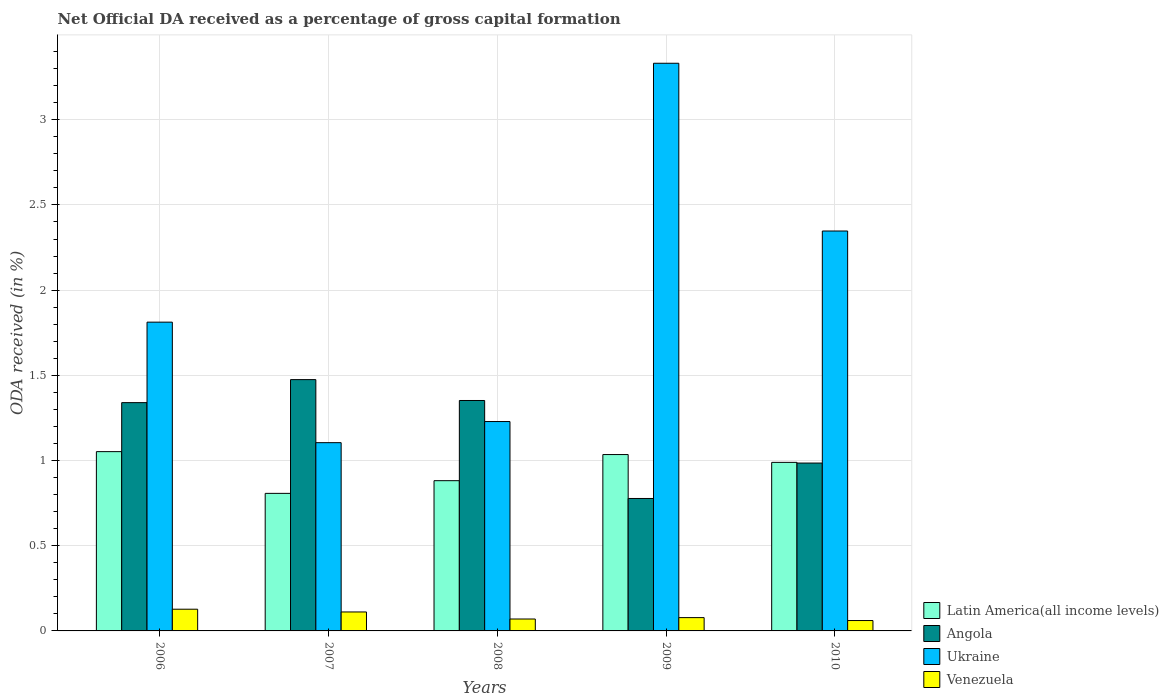How many different coloured bars are there?
Offer a terse response. 4. Are the number of bars per tick equal to the number of legend labels?
Give a very brief answer. Yes. How many bars are there on the 1st tick from the left?
Your answer should be very brief. 4. How many bars are there on the 3rd tick from the right?
Ensure brevity in your answer.  4. What is the net ODA received in Angola in 2009?
Your answer should be compact. 0.78. Across all years, what is the maximum net ODA received in Ukraine?
Your response must be concise. 3.33. Across all years, what is the minimum net ODA received in Angola?
Give a very brief answer. 0.78. In which year was the net ODA received in Latin America(all income levels) maximum?
Your answer should be very brief. 2006. In which year was the net ODA received in Latin America(all income levels) minimum?
Provide a succinct answer. 2007. What is the total net ODA received in Angola in the graph?
Your answer should be very brief. 5.93. What is the difference between the net ODA received in Latin America(all income levels) in 2008 and that in 2009?
Make the answer very short. -0.15. What is the difference between the net ODA received in Ukraine in 2010 and the net ODA received in Latin America(all income levels) in 2006?
Provide a short and direct response. 1.29. What is the average net ODA received in Latin America(all income levels) per year?
Your response must be concise. 0.95. In the year 2007, what is the difference between the net ODA received in Angola and net ODA received in Ukraine?
Ensure brevity in your answer.  0.37. In how many years, is the net ODA received in Angola greater than 2.5 %?
Offer a terse response. 0. What is the ratio of the net ODA received in Angola in 2007 to that in 2009?
Your answer should be very brief. 1.9. Is the net ODA received in Venezuela in 2009 less than that in 2010?
Make the answer very short. No. What is the difference between the highest and the second highest net ODA received in Angola?
Your answer should be very brief. 0.12. What is the difference between the highest and the lowest net ODA received in Angola?
Ensure brevity in your answer.  0.7. Is the sum of the net ODA received in Angola in 2007 and 2010 greater than the maximum net ODA received in Venezuela across all years?
Your answer should be compact. Yes. What does the 4th bar from the left in 2006 represents?
Your answer should be compact. Venezuela. What does the 2nd bar from the right in 2010 represents?
Offer a very short reply. Ukraine. What is the difference between two consecutive major ticks on the Y-axis?
Provide a succinct answer. 0.5. Are the values on the major ticks of Y-axis written in scientific E-notation?
Your answer should be compact. No. Does the graph contain any zero values?
Provide a short and direct response. No. Does the graph contain grids?
Make the answer very short. Yes. What is the title of the graph?
Your answer should be compact. Net Official DA received as a percentage of gross capital formation. What is the label or title of the X-axis?
Provide a short and direct response. Years. What is the label or title of the Y-axis?
Provide a short and direct response. ODA received (in %). What is the ODA received (in %) in Latin America(all income levels) in 2006?
Keep it short and to the point. 1.05. What is the ODA received (in %) in Angola in 2006?
Offer a terse response. 1.34. What is the ODA received (in %) in Ukraine in 2006?
Provide a succinct answer. 1.81. What is the ODA received (in %) of Venezuela in 2006?
Your answer should be compact. 0.13. What is the ODA received (in %) in Latin America(all income levels) in 2007?
Your response must be concise. 0.81. What is the ODA received (in %) of Angola in 2007?
Your answer should be very brief. 1.47. What is the ODA received (in %) in Ukraine in 2007?
Offer a terse response. 1.1. What is the ODA received (in %) in Venezuela in 2007?
Give a very brief answer. 0.11. What is the ODA received (in %) in Latin America(all income levels) in 2008?
Offer a very short reply. 0.88. What is the ODA received (in %) in Angola in 2008?
Your answer should be very brief. 1.35. What is the ODA received (in %) in Ukraine in 2008?
Offer a terse response. 1.23. What is the ODA received (in %) in Venezuela in 2008?
Provide a short and direct response. 0.07. What is the ODA received (in %) in Latin America(all income levels) in 2009?
Make the answer very short. 1.04. What is the ODA received (in %) in Angola in 2009?
Provide a short and direct response. 0.78. What is the ODA received (in %) in Ukraine in 2009?
Keep it short and to the point. 3.33. What is the ODA received (in %) of Venezuela in 2009?
Keep it short and to the point. 0.08. What is the ODA received (in %) in Latin America(all income levels) in 2010?
Make the answer very short. 0.99. What is the ODA received (in %) of Angola in 2010?
Make the answer very short. 0.99. What is the ODA received (in %) of Ukraine in 2010?
Ensure brevity in your answer.  2.35. What is the ODA received (in %) of Venezuela in 2010?
Ensure brevity in your answer.  0.06. Across all years, what is the maximum ODA received (in %) in Latin America(all income levels)?
Offer a terse response. 1.05. Across all years, what is the maximum ODA received (in %) in Angola?
Offer a very short reply. 1.47. Across all years, what is the maximum ODA received (in %) of Ukraine?
Offer a terse response. 3.33. Across all years, what is the maximum ODA received (in %) in Venezuela?
Offer a very short reply. 0.13. Across all years, what is the minimum ODA received (in %) in Latin America(all income levels)?
Ensure brevity in your answer.  0.81. Across all years, what is the minimum ODA received (in %) of Angola?
Offer a terse response. 0.78. Across all years, what is the minimum ODA received (in %) in Ukraine?
Give a very brief answer. 1.1. Across all years, what is the minimum ODA received (in %) of Venezuela?
Provide a short and direct response. 0.06. What is the total ODA received (in %) in Latin America(all income levels) in the graph?
Provide a succinct answer. 4.77. What is the total ODA received (in %) of Angola in the graph?
Make the answer very short. 5.93. What is the total ODA received (in %) of Ukraine in the graph?
Your response must be concise. 9.82. What is the total ODA received (in %) in Venezuela in the graph?
Your response must be concise. 0.45. What is the difference between the ODA received (in %) of Latin America(all income levels) in 2006 and that in 2007?
Ensure brevity in your answer.  0.24. What is the difference between the ODA received (in %) of Angola in 2006 and that in 2007?
Give a very brief answer. -0.14. What is the difference between the ODA received (in %) in Ukraine in 2006 and that in 2007?
Keep it short and to the point. 0.71. What is the difference between the ODA received (in %) of Venezuela in 2006 and that in 2007?
Make the answer very short. 0.02. What is the difference between the ODA received (in %) of Latin America(all income levels) in 2006 and that in 2008?
Provide a succinct answer. 0.17. What is the difference between the ODA received (in %) in Angola in 2006 and that in 2008?
Provide a succinct answer. -0.01. What is the difference between the ODA received (in %) of Ukraine in 2006 and that in 2008?
Provide a succinct answer. 0.58. What is the difference between the ODA received (in %) in Venezuela in 2006 and that in 2008?
Your response must be concise. 0.06. What is the difference between the ODA received (in %) in Latin America(all income levels) in 2006 and that in 2009?
Provide a succinct answer. 0.02. What is the difference between the ODA received (in %) of Angola in 2006 and that in 2009?
Make the answer very short. 0.56. What is the difference between the ODA received (in %) of Ukraine in 2006 and that in 2009?
Ensure brevity in your answer.  -1.52. What is the difference between the ODA received (in %) in Venezuela in 2006 and that in 2009?
Offer a terse response. 0.05. What is the difference between the ODA received (in %) in Latin America(all income levels) in 2006 and that in 2010?
Provide a succinct answer. 0.06. What is the difference between the ODA received (in %) in Angola in 2006 and that in 2010?
Keep it short and to the point. 0.35. What is the difference between the ODA received (in %) of Ukraine in 2006 and that in 2010?
Keep it short and to the point. -0.53. What is the difference between the ODA received (in %) in Venezuela in 2006 and that in 2010?
Your answer should be very brief. 0.07. What is the difference between the ODA received (in %) of Latin America(all income levels) in 2007 and that in 2008?
Make the answer very short. -0.07. What is the difference between the ODA received (in %) of Angola in 2007 and that in 2008?
Offer a terse response. 0.12. What is the difference between the ODA received (in %) of Ukraine in 2007 and that in 2008?
Your answer should be very brief. -0.12. What is the difference between the ODA received (in %) in Venezuela in 2007 and that in 2008?
Give a very brief answer. 0.04. What is the difference between the ODA received (in %) of Latin America(all income levels) in 2007 and that in 2009?
Your answer should be compact. -0.23. What is the difference between the ODA received (in %) in Angola in 2007 and that in 2009?
Make the answer very short. 0.7. What is the difference between the ODA received (in %) of Ukraine in 2007 and that in 2009?
Give a very brief answer. -2.23. What is the difference between the ODA received (in %) in Venezuela in 2007 and that in 2009?
Give a very brief answer. 0.03. What is the difference between the ODA received (in %) in Latin America(all income levels) in 2007 and that in 2010?
Give a very brief answer. -0.18. What is the difference between the ODA received (in %) of Angola in 2007 and that in 2010?
Your answer should be very brief. 0.49. What is the difference between the ODA received (in %) in Ukraine in 2007 and that in 2010?
Your response must be concise. -1.24. What is the difference between the ODA received (in %) of Venezuela in 2007 and that in 2010?
Offer a terse response. 0.05. What is the difference between the ODA received (in %) of Latin America(all income levels) in 2008 and that in 2009?
Offer a very short reply. -0.15. What is the difference between the ODA received (in %) of Angola in 2008 and that in 2009?
Offer a very short reply. 0.58. What is the difference between the ODA received (in %) of Ukraine in 2008 and that in 2009?
Keep it short and to the point. -2.1. What is the difference between the ODA received (in %) in Venezuela in 2008 and that in 2009?
Give a very brief answer. -0.01. What is the difference between the ODA received (in %) of Latin America(all income levels) in 2008 and that in 2010?
Give a very brief answer. -0.11. What is the difference between the ODA received (in %) of Angola in 2008 and that in 2010?
Offer a terse response. 0.37. What is the difference between the ODA received (in %) of Ukraine in 2008 and that in 2010?
Keep it short and to the point. -1.12. What is the difference between the ODA received (in %) in Venezuela in 2008 and that in 2010?
Make the answer very short. 0.01. What is the difference between the ODA received (in %) in Latin America(all income levels) in 2009 and that in 2010?
Your response must be concise. 0.05. What is the difference between the ODA received (in %) of Angola in 2009 and that in 2010?
Offer a very short reply. -0.21. What is the difference between the ODA received (in %) of Ukraine in 2009 and that in 2010?
Provide a succinct answer. 0.98. What is the difference between the ODA received (in %) of Venezuela in 2009 and that in 2010?
Give a very brief answer. 0.02. What is the difference between the ODA received (in %) in Latin America(all income levels) in 2006 and the ODA received (in %) in Angola in 2007?
Give a very brief answer. -0.42. What is the difference between the ODA received (in %) in Latin America(all income levels) in 2006 and the ODA received (in %) in Ukraine in 2007?
Offer a terse response. -0.05. What is the difference between the ODA received (in %) in Latin America(all income levels) in 2006 and the ODA received (in %) in Venezuela in 2007?
Ensure brevity in your answer.  0.94. What is the difference between the ODA received (in %) in Angola in 2006 and the ODA received (in %) in Ukraine in 2007?
Provide a short and direct response. 0.23. What is the difference between the ODA received (in %) of Angola in 2006 and the ODA received (in %) of Venezuela in 2007?
Provide a succinct answer. 1.23. What is the difference between the ODA received (in %) in Ukraine in 2006 and the ODA received (in %) in Venezuela in 2007?
Ensure brevity in your answer.  1.7. What is the difference between the ODA received (in %) in Latin America(all income levels) in 2006 and the ODA received (in %) in Angola in 2008?
Give a very brief answer. -0.3. What is the difference between the ODA received (in %) of Latin America(all income levels) in 2006 and the ODA received (in %) of Ukraine in 2008?
Provide a succinct answer. -0.18. What is the difference between the ODA received (in %) in Latin America(all income levels) in 2006 and the ODA received (in %) in Venezuela in 2008?
Your answer should be compact. 0.98. What is the difference between the ODA received (in %) in Angola in 2006 and the ODA received (in %) in Ukraine in 2008?
Make the answer very short. 0.11. What is the difference between the ODA received (in %) of Angola in 2006 and the ODA received (in %) of Venezuela in 2008?
Keep it short and to the point. 1.27. What is the difference between the ODA received (in %) in Ukraine in 2006 and the ODA received (in %) in Venezuela in 2008?
Give a very brief answer. 1.74. What is the difference between the ODA received (in %) in Latin America(all income levels) in 2006 and the ODA received (in %) in Angola in 2009?
Offer a terse response. 0.27. What is the difference between the ODA received (in %) of Latin America(all income levels) in 2006 and the ODA received (in %) of Ukraine in 2009?
Offer a terse response. -2.28. What is the difference between the ODA received (in %) in Latin America(all income levels) in 2006 and the ODA received (in %) in Venezuela in 2009?
Your response must be concise. 0.97. What is the difference between the ODA received (in %) of Angola in 2006 and the ODA received (in %) of Ukraine in 2009?
Provide a short and direct response. -1.99. What is the difference between the ODA received (in %) of Angola in 2006 and the ODA received (in %) of Venezuela in 2009?
Keep it short and to the point. 1.26. What is the difference between the ODA received (in %) of Ukraine in 2006 and the ODA received (in %) of Venezuela in 2009?
Your answer should be compact. 1.73. What is the difference between the ODA received (in %) in Latin America(all income levels) in 2006 and the ODA received (in %) in Angola in 2010?
Your answer should be compact. 0.07. What is the difference between the ODA received (in %) of Latin America(all income levels) in 2006 and the ODA received (in %) of Ukraine in 2010?
Your answer should be compact. -1.29. What is the difference between the ODA received (in %) in Latin America(all income levels) in 2006 and the ODA received (in %) in Venezuela in 2010?
Keep it short and to the point. 0.99. What is the difference between the ODA received (in %) of Angola in 2006 and the ODA received (in %) of Ukraine in 2010?
Give a very brief answer. -1.01. What is the difference between the ODA received (in %) in Angola in 2006 and the ODA received (in %) in Venezuela in 2010?
Make the answer very short. 1.28. What is the difference between the ODA received (in %) of Ukraine in 2006 and the ODA received (in %) of Venezuela in 2010?
Your response must be concise. 1.75. What is the difference between the ODA received (in %) in Latin America(all income levels) in 2007 and the ODA received (in %) in Angola in 2008?
Your response must be concise. -0.55. What is the difference between the ODA received (in %) of Latin America(all income levels) in 2007 and the ODA received (in %) of Ukraine in 2008?
Ensure brevity in your answer.  -0.42. What is the difference between the ODA received (in %) in Latin America(all income levels) in 2007 and the ODA received (in %) in Venezuela in 2008?
Provide a short and direct response. 0.74. What is the difference between the ODA received (in %) of Angola in 2007 and the ODA received (in %) of Ukraine in 2008?
Your answer should be compact. 0.25. What is the difference between the ODA received (in %) of Angola in 2007 and the ODA received (in %) of Venezuela in 2008?
Your answer should be very brief. 1.4. What is the difference between the ODA received (in %) of Ukraine in 2007 and the ODA received (in %) of Venezuela in 2008?
Your response must be concise. 1.03. What is the difference between the ODA received (in %) in Latin America(all income levels) in 2007 and the ODA received (in %) in Angola in 2009?
Keep it short and to the point. 0.03. What is the difference between the ODA received (in %) in Latin America(all income levels) in 2007 and the ODA received (in %) in Ukraine in 2009?
Offer a terse response. -2.52. What is the difference between the ODA received (in %) of Latin America(all income levels) in 2007 and the ODA received (in %) of Venezuela in 2009?
Your response must be concise. 0.73. What is the difference between the ODA received (in %) of Angola in 2007 and the ODA received (in %) of Ukraine in 2009?
Ensure brevity in your answer.  -1.86. What is the difference between the ODA received (in %) in Angola in 2007 and the ODA received (in %) in Venezuela in 2009?
Your answer should be very brief. 1.4. What is the difference between the ODA received (in %) in Ukraine in 2007 and the ODA received (in %) in Venezuela in 2009?
Your answer should be compact. 1.03. What is the difference between the ODA received (in %) in Latin America(all income levels) in 2007 and the ODA received (in %) in Angola in 2010?
Ensure brevity in your answer.  -0.18. What is the difference between the ODA received (in %) in Latin America(all income levels) in 2007 and the ODA received (in %) in Ukraine in 2010?
Your answer should be compact. -1.54. What is the difference between the ODA received (in %) in Latin America(all income levels) in 2007 and the ODA received (in %) in Venezuela in 2010?
Offer a very short reply. 0.75. What is the difference between the ODA received (in %) in Angola in 2007 and the ODA received (in %) in Ukraine in 2010?
Your answer should be compact. -0.87. What is the difference between the ODA received (in %) in Angola in 2007 and the ODA received (in %) in Venezuela in 2010?
Offer a terse response. 1.41. What is the difference between the ODA received (in %) of Ukraine in 2007 and the ODA received (in %) of Venezuela in 2010?
Provide a succinct answer. 1.04. What is the difference between the ODA received (in %) in Latin America(all income levels) in 2008 and the ODA received (in %) in Angola in 2009?
Offer a terse response. 0.1. What is the difference between the ODA received (in %) in Latin America(all income levels) in 2008 and the ODA received (in %) in Ukraine in 2009?
Offer a terse response. -2.45. What is the difference between the ODA received (in %) of Latin America(all income levels) in 2008 and the ODA received (in %) of Venezuela in 2009?
Your answer should be compact. 0.8. What is the difference between the ODA received (in %) of Angola in 2008 and the ODA received (in %) of Ukraine in 2009?
Ensure brevity in your answer.  -1.98. What is the difference between the ODA received (in %) of Angola in 2008 and the ODA received (in %) of Venezuela in 2009?
Keep it short and to the point. 1.27. What is the difference between the ODA received (in %) in Ukraine in 2008 and the ODA received (in %) in Venezuela in 2009?
Provide a short and direct response. 1.15. What is the difference between the ODA received (in %) of Latin America(all income levels) in 2008 and the ODA received (in %) of Angola in 2010?
Your response must be concise. -0.1. What is the difference between the ODA received (in %) in Latin America(all income levels) in 2008 and the ODA received (in %) in Ukraine in 2010?
Ensure brevity in your answer.  -1.47. What is the difference between the ODA received (in %) of Latin America(all income levels) in 2008 and the ODA received (in %) of Venezuela in 2010?
Your answer should be compact. 0.82. What is the difference between the ODA received (in %) in Angola in 2008 and the ODA received (in %) in Ukraine in 2010?
Provide a succinct answer. -0.99. What is the difference between the ODA received (in %) in Angola in 2008 and the ODA received (in %) in Venezuela in 2010?
Provide a short and direct response. 1.29. What is the difference between the ODA received (in %) in Ukraine in 2008 and the ODA received (in %) in Venezuela in 2010?
Your answer should be compact. 1.17. What is the difference between the ODA received (in %) in Latin America(all income levels) in 2009 and the ODA received (in %) in Angola in 2010?
Provide a succinct answer. 0.05. What is the difference between the ODA received (in %) of Latin America(all income levels) in 2009 and the ODA received (in %) of Ukraine in 2010?
Provide a succinct answer. -1.31. What is the difference between the ODA received (in %) in Latin America(all income levels) in 2009 and the ODA received (in %) in Venezuela in 2010?
Make the answer very short. 0.97. What is the difference between the ODA received (in %) of Angola in 2009 and the ODA received (in %) of Ukraine in 2010?
Your answer should be compact. -1.57. What is the difference between the ODA received (in %) of Angola in 2009 and the ODA received (in %) of Venezuela in 2010?
Make the answer very short. 0.72. What is the difference between the ODA received (in %) of Ukraine in 2009 and the ODA received (in %) of Venezuela in 2010?
Make the answer very short. 3.27. What is the average ODA received (in %) of Latin America(all income levels) per year?
Provide a short and direct response. 0.95. What is the average ODA received (in %) of Angola per year?
Your response must be concise. 1.19. What is the average ODA received (in %) in Ukraine per year?
Your answer should be very brief. 1.96. What is the average ODA received (in %) in Venezuela per year?
Make the answer very short. 0.09. In the year 2006, what is the difference between the ODA received (in %) in Latin America(all income levels) and ODA received (in %) in Angola?
Provide a short and direct response. -0.29. In the year 2006, what is the difference between the ODA received (in %) of Latin America(all income levels) and ODA received (in %) of Ukraine?
Keep it short and to the point. -0.76. In the year 2006, what is the difference between the ODA received (in %) of Latin America(all income levels) and ODA received (in %) of Venezuela?
Keep it short and to the point. 0.92. In the year 2006, what is the difference between the ODA received (in %) of Angola and ODA received (in %) of Ukraine?
Your answer should be very brief. -0.47. In the year 2006, what is the difference between the ODA received (in %) in Angola and ODA received (in %) in Venezuela?
Your answer should be very brief. 1.21. In the year 2006, what is the difference between the ODA received (in %) of Ukraine and ODA received (in %) of Venezuela?
Offer a terse response. 1.68. In the year 2007, what is the difference between the ODA received (in %) of Latin America(all income levels) and ODA received (in %) of Angola?
Give a very brief answer. -0.67. In the year 2007, what is the difference between the ODA received (in %) in Latin America(all income levels) and ODA received (in %) in Ukraine?
Provide a succinct answer. -0.3. In the year 2007, what is the difference between the ODA received (in %) in Latin America(all income levels) and ODA received (in %) in Venezuela?
Offer a terse response. 0.7. In the year 2007, what is the difference between the ODA received (in %) of Angola and ODA received (in %) of Ukraine?
Your answer should be compact. 0.37. In the year 2007, what is the difference between the ODA received (in %) of Angola and ODA received (in %) of Venezuela?
Provide a short and direct response. 1.36. In the year 2007, what is the difference between the ODA received (in %) in Ukraine and ODA received (in %) in Venezuela?
Offer a very short reply. 0.99. In the year 2008, what is the difference between the ODA received (in %) of Latin America(all income levels) and ODA received (in %) of Angola?
Your answer should be compact. -0.47. In the year 2008, what is the difference between the ODA received (in %) in Latin America(all income levels) and ODA received (in %) in Ukraine?
Provide a succinct answer. -0.35. In the year 2008, what is the difference between the ODA received (in %) of Latin America(all income levels) and ODA received (in %) of Venezuela?
Ensure brevity in your answer.  0.81. In the year 2008, what is the difference between the ODA received (in %) of Angola and ODA received (in %) of Ukraine?
Your response must be concise. 0.12. In the year 2008, what is the difference between the ODA received (in %) in Angola and ODA received (in %) in Venezuela?
Provide a succinct answer. 1.28. In the year 2008, what is the difference between the ODA received (in %) of Ukraine and ODA received (in %) of Venezuela?
Offer a very short reply. 1.16. In the year 2009, what is the difference between the ODA received (in %) of Latin America(all income levels) and ODA received (in %) of Angola?
Provide a succinct answer. 0.26. In the year 2009, what is the difference between the ODA received (in %) of Latin America(all income levels) and ODA received (in %) of Ukraine?
Give a very brief answer. -2.3. In the year 2009, what is the difference between the ODA received (in %) in Latin America(all income levels) and ODA received (in %) in Venezuela?
Provide a succinct answer. 0.96. In the year 2009, what is the difference between the ODA received (in %) in Angola and ODA received (in %) in Ukraine?
Give a very brief answer. -2.55. In the year 2009, what is the difference between the ODA received (in %) of Angola and ODA received (in %) of Venezuela?
Make the answer very short. 0.7. In the year 2009, what is the difference between the ODA received (in %) of Ukraine and ODA received (in %) of Venezuela?
Your response must be concise. 3.25. In the year 2010, what is the difference between the ODA received (in %) in Latin America(all income levels) and ODA received (in %) in Angola?
Your answer should be compact. 0. In the year 2010, what is the difference between the ODA received (in %) in Latin America(all income levels) and ODA received (in %) in Ukraine?
Offer a terse response. -1.36. In the year 2010, what is the difference between the ODA received (in %) in Latin America(all income levels) and ODA received (in %) in Venezuela?
Your response must be concise. 0.93. In the year 2010, what is the difference between the ODA received (in %) in Angola and ODA received (in %) in Ukraine?
Provide a short and direct response. -1.36. In the year 2010, what is the difference between the ODA received (in %) in Angola and ODA received (in %) in Venezuela?
Your answer should be compact. 0.92. In the year 2010, what is the difference between the ODA received (in %) of Ukraine and ODA received (in %) of Venezuela?
Offer a terse response. 2.29. What is the ratio of the ODA received (in %) in Latin America(all income levels) in 2006 to that in 2007?
Offer a very short reply. 1.3. What is the ratio of the ODA received (in %) of Angola in 2006 to that in 2007?
Offer a very short reply. 0.91. What is the ratio of the ODA received (in %) of Ukraine in 2006 to that in 2007?
Keep it short and to the point. 1.64. What is the ratio of the ODA received (in %) of Venezuela in 2006 to that in 2007?
Give a very brief answer. 1.15. What is the ratio of the ODA received (in %) in Latin America(all income levels) in 2006 to that in 2008?
Your answer should be compact. 1.19. What is the ratio of the ODA received (in %) in Ukraine in 2006 to that in 2008?
Your answer should be very brief. 1.47. What is the ratio of the ODA received (in %) in Venezuela in 2006 to that in 2008?
Give a very brief answer. 1.82. What is the ratio of the ODA received (in %) of Latin America(all income levels) in 2006 to that in 2009?
Give a very brief answer. 1.02. What is the ratio of the ODA received (in %) of Angola in 2006 to that in 2009?
Offer a terse response. 1.72. What is the ratio of the ODA received (in %) of Ukraine in 2006 to that in 2009?
Your answer should be compact. 0.54. What is the ratio of the ODA received (in %) of Venezuela in 2006 to that in 2009?
Provide a short and direct response. 1.63. What is the ratio of the ODA received (in %) in Latin America(all income levels) in 2006 to that in 2010?
Give a very brief answer. 1.06. What is the ratio of the ODA received (in %) in Angola in 2006 to that in 2010?
Your response must be concise. 1.36. What is the ratio of the ODA received (in %) of Ukraine in 2006 to that in 2010?
Give a very brief answer. 0.77. What is the ratio of the ODA received (in %) in Venezuela in 2006 to that in 2010?
Provide a short and direct response. 2.09. What is the ratio of the ODA received (in %) of Latin America(all income levels) in 2007 to that in 2008?
Your answer should be compact. 0.92. What is the ratio of the ODA received (in %) of Angola in 2007 to that in 2008?
Keep it short and to the point. 1.09. What is the ratio of the ODA received (in %) in Ukraine in 2007 to that in 2008?
Give a very brief answer. 0.9. What is the ratio of the ODA received (in %) in Venezuela in 2007 to that in 2008?
Make the answer very short. 1.59. What is the ratio of the ODA received (in %) in Latin America(all income levels) in 2007 to that in 2009?
Offer a very short reply. 0.78. What is the ratio of the ODA received (in %) of Angola in 2007 to that in 2009?
Offer a terse response. 1.9. What is the ratio of the ODA received (in %) in Ukraine in 2007 to that in 2009?
Keep it short and to the point. 0.33. What is the ratio of the ODA received (in %) in Venezuela in 2007 to that in 2009?
Provide a short and direct response. 1.43. What is the ratio of the ODA received (in %) in Latin America(all income levels) in 2007 to that in 2010?
Your response must be concise. 0.82. What is the ratio of the ODA received (in %) of Angola in 2007 to that in 2010?
Give a very brief answer. 1.5. What is the ratio of the ODA received (in %) in Ukraine in 2007 to that in 2010?
Provide a short and direct response. 0.47. What is the ratio of the ODA received (in %) in Venezuela in 2007 to that in 2010?
Your answer should be compact. 1.83. What is the ratio of the ODA received (in %) in Latin America(all income levels) in 2008 to that in 2009?
Your answer should be very brief. 0.85. What is the ratio of the ODA received (in %) of Angola in 2008 to that in 2009?
Provide a short and direct response. 1.74. What is the ratio of the ODA received (in %) in Ukraine in 2008 to that in 2009?
Provide a succinct answer. 0.37. What is the ratio of the ODA received (in %) of Venezuela in 2008 to that in 2009?
Give a very brief answer. 0.9. What is the ratio of the ODA received (in %) of Latin America(all income levels) in 2008 to that in 2010?
Your answer should be compact. 0.89. What is the ratio of the ODA received (in %) of Angola in 2008 to that in 2010?
Offer a terse response. 1.37. What is the ratio of the ODA received (in %) in Ukraine in 2008 to that in 2010?
Your answer should be compact. 0.52. What is the ratio of the ODA received (in %) in Venezuela in 2008 to that in 2010?
Offer a very short reply. 1.15. What is the ratio of the ODA received (in %) of Latin America(all income levels) in 2009 to that in 2010?
Keep it short and to the point. 1.05. What is the ratio of the ODA received (in %) of Angola in 2009 to that in 2010?
Your answer should be very brief. 0.79. What is the ratio of the ODA received (in %) in Ukraine in 2009 to that in 2010?
Provide a succinct answer. 1.42. What is the ratio of the ODA received (in %) of Venezuela in 2009 to that in 2010?
Keep it short and to the point. 1.28. What is the difference between the highest and the second highest ODA received (in %) of Latin America(all income levels)?
Your answer should be compact. 0.02. What is the difference between the highest and the second highest ODA received (in %) of Angola?
Provide a succinct answer. 0.12. What is the difference between the highest and the second highest ODA received (in %) of Ukraine?
Make the answer very short. 0.98. What is the difference between the highest and the second highest ODA received (in %) in Venezuela?
Provide a short and direct response. 0.02. What is the difference between the highest and the lowest ODA received (in %) of Latin America(all income levels)?
Give a very brief answer. 0.24. What is the difference between the highest and the lowest ODA received (in %) in Angola?
Make the answer very short. 0.7. What is the difference between the highest and the lowest ODA received (in %) in Ukraine?
Keep it short and to the point. 2.23. What is the difference between the highest and the lowest ODA received (in %) of Venezuela?
Give a very brief answer. 0.07. 